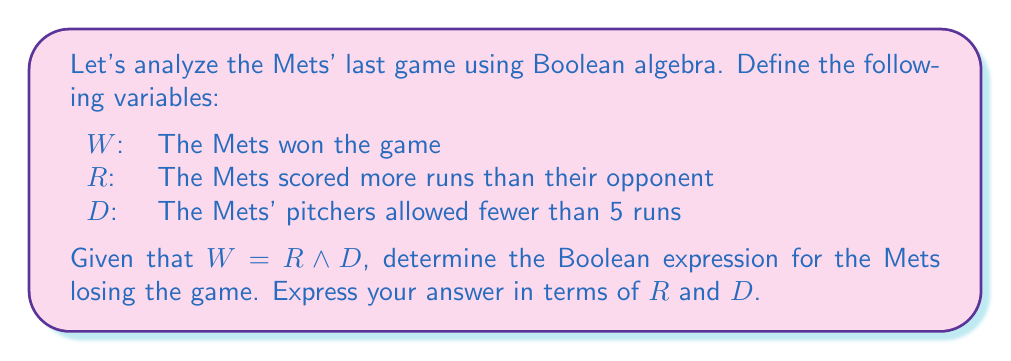Show me your answer to this math problem. Let's approach this step-by-step:

1) We're given that $W = R \wedge D$, which means the Mets win if they score more runs than their opponent AND their pitchers allow fewer than 5 runs.

2) To find the expression for the Mets losing the game, we need to negate $W$. Let's call this $L$ (for Loss).

3) $L = \neg W$

4) Using De Morgan's law, we can negate $R \wedge D$:
   $L = \neg (R \wedge D) = \neg R \vee \neg D$

5) This means the Mets lose if they don't score more runs than their opponent OR their pitchers allow 5 or more runs.

6) Therefore, the Boolean expression for the Mets losing the game is $\neg R \vee \neg D$.
Answer: $\neg R \vee \neg D$ 